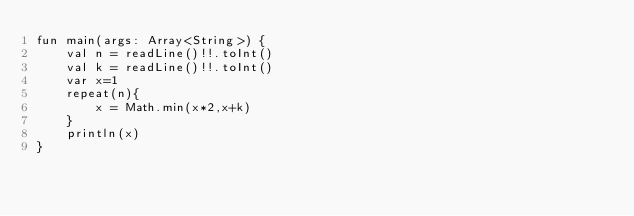<code> <loc_0><loc_0><loc_500><loc_500><_Kotlin_>fun main(args: Array<String>) {
    val n = readLine()!!.toInt()
    val k = readLine()!!.toInt()
    var x=1
    repeat(n){
        x = Math.min(x*2,x+k)
    }
    println(x)
}</code> 